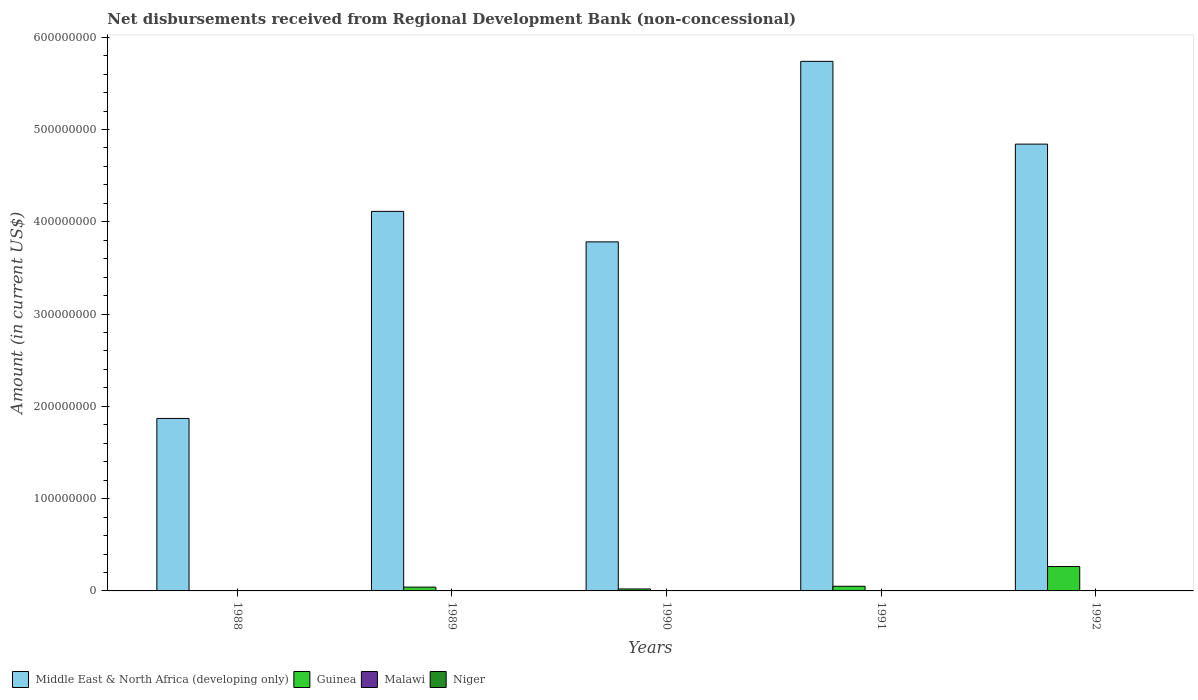How many different coloured bars are there?
Your response must be concise. 2. How many bars are there on the 2nd tick from the left?
Provide a short and direct response. 2. In how many cases, is the number of bars for a given year not equal to the number of legend labels?
Provide a succinct answer. 5. What is the amount of disbursements received from Regional Development Bank in Guinea in 1990?
Provide a short and direct response. 2.14e+06. Across all years, what is the maximum amount of disbursements received from Regional Development Bank in Middle East & North Africa (developing only)?
Offer a terse response. 5.74e+08. In which year was the amount of disbursements received from Regional Development Bank in Middle East & North Africa (developing only) maximum?
Your response must be concise. 1991. What is the total amount of disbursements received from Regional Development Bank in Guinea in the graph?
Make the answer very short. 3.77e+07. What is the difference between the amount of disbursements received from Regional Development Bank in Middle East & North Africa (developing only) in 1988 and that in 1990?
Your answer should be compact. -1.91e+08. What is the difference between the amount of disbursements received from Regional Development Bank in Guinea in 1992 and the amount of disbursements received from Regional Development Bank in Niger in 1990?
Ensure brevity in your answer.  2.64e+07. What is the average amount of disbursements received from Regional Development Bank in Middle East & North Africa (developing only) per year?
Make the answer very short. 4.07e+08. In how many years, is the amount of disbursements received from Regional Development Bank in Guinea greater than 140000000 US$?
Keep it short and to the point. 0. What is the ratio of the amount of disbursements received from Regional Development Bank in Guinea in 1989 to that in 1992?
Make the answer very short. 0.16. What is the difference between the highest and the second highest amount of disbursements received from Regional Development Bank in Guinea?
Your answer should be compact. 2.14e+07. What is the difference between the highest and the lowest amount of disbursements received from Regional Development Bank in Middle East & North Africa (developing only)?
Your answer should be very brief. 3.87e+08. Is the sum of the amount of disbursements received from Regional Development Bank in Guinea in 1989 and 1990 greater than the maximum amount of disbursements received from Regional Development Bank in Malawi across all years?
Give a very brief answer. Yes. Is it the case that in every year, the sum of the amount of disbursements received from Regional Development Bank in Middle East & North Africa (developing only) and amount of disbursements received from Regional Development Bank in Malawi is greater than the sum of amount of disbursements received from Regional Development Bank in Niger and amount of disbursements received from Regional Development Bank in Guinea?
Offer a very short reply. Yes. Is it the case that in every year, the sum of the amount of disbursements received from Regional Development Bank in Middle East & North Africa (developing only) and amount of disbursements received from Regional Development Bank in Niger is greater than the amount of disbursements received from Regional Development Bank in Malawi?
Make the answer very short. Yes. How many bars are there?
Your response must be concise. 9. Are all the bars in the graph horizontal?
Your answer should be compact. No. Does the graph contain grids?
Your response must be concise. No. How many legend labels are there?
Provide a short and direct response. 4. How are the legend labels stacked?
Make the answer very short. Horizontal. What is the title of the graph?
Give a very brief answer. Net disbursements received from Regional Development Bank (non-concessional). Does "Eritrea" appear as one of the legend labels in the graph?
Provide a succinct answer. No. What is the label or title of the X-axis?
Ensure brevity in your answer.  Years. What is the label or title of the Y-axis?
Provide a succinct answer. Amount (in current US$). What is the Amount (in current US$) in Middle East & North Africa (developing only) in 1988?
Offer a very short reply. 1.87e+08. What is the Amount (in current US$) of Malawi in 1988?
Your answer should be very brief. 0. What is the Amount (in current US$) in Middle East & North Africa (developing only) in 1989?
Give a very brief answer. 4.11e+08. What is the Amount (in current US$) in Guinea in 1989?
Ensure brevity in your answer.  4.12e+06. What is the Amount (in current US$) of Malawi in 1989?
Keep it short and to the point. 0. What is the Amount (in current US$) in Niger in 1989?
Provide a short and direct response. 0. What is the Amount (in current US$) of Middle East & North Africa (developing only) in 1990?
Offer a terse response. 3.78e+08. What is the Amount (in current US$) of Guinea in 1990?
Provide a short and direct response. 2.14e+06. What is the Amount (in current US$) in Middle East & North Africa (developing only) in 1991?
Offer a very short reply. 5.74e+08. What is the Amount (in current US$) in Guinea in 1991?
Your answer should be compact. 5.05e+06. What is the Amount (in current US$) in Middle East & North Africa (developing only) in 1992?
Your answer should be very brief. 4.84e+08. What is the Amount (in current US$) in Guinea in 1992?
Give a very brief answer. 2.64e+07. What is the Amount (in current US$) in Niger in 1992?
Offer a terse response. 0. Across all years, what is the maximum Amount (in current US$) of Middle East & North Africa (developing only)?
Provide a succinct answer. 5.74e+08. Across all years, what is the maximum Amount (in current US$) of Guinea?
Make the answer very short. 2.64e+07. Across all years, what is the minimum Amount (in current US$) of Middle East & North Africa (developing only)?
Your answer should be very brief. 1.87e+08. What is the total Amount (in current US$) of Middle East & North Africa (developing only) in the graph?
Your answer should be compact. 2.03e+09. What is the total Amount (in current US$) of Guinea in the graph?
Ensure brevity in your answer.  3.77e+07. What is the difference between the Amount (in current US$) in Middle East & North Africa (developing only) in 1988 and that in 1989?
Ensure brevity in your answer.  -2.24e+08. What is the difference between the Amount (in current US$) in Middle East & North Africa (developing only) in 1988 and that in 1990?
Your answer should be compact. -1.91e+08. What is the difference between the Amount (in current US$) of Middle East & North Africa (developing only) in 1988 and that in 1991?
Your response must be concise. -3.87e+08. What is the difference between the Amount (in current US$) of Middle East & North Africa (developing only) in 1988 and that in 1992?
Your answer should be very brief. -2.97e+08. What is the difference between the Amount (in current US$) in Middle East & North Africa (developing only) in 1989 and that in 1990?
Make the answer very short. 3.30e+07. What is the difference between the Amount (in current US$) of Guinea in 1989 and that in 1990?
Your response must be concise. 1.98e+06. What is the difference between the Amount (in current US$) of Middle East & North Africa (developing only) in 1989 and that in 1991?
Your answer should be compact. -1.63e+08. What is the difference between the Amount (in current US$) in Guinea in 1989 and that in 1991?
Keep it short and to the point. -9.35e+05. What is the difference between the Amount (in current US$) in Middle East & North Africa (developing only) in 1989 and that in 1992?
Offer a terse response. -7.29e+07. What is the difference between the Amount (in current US$) in Guinea in 1989 and that in 1992?
Your response must be concise. -2.23e+07. What is the difference between the Amount (in current US$) in Middle East & North Africa (developing only) in 1990 and that in 1991?
Your answer should be very brief. -1.96e+08. What is the difference between the Amount (in current US$) of Guinea in 1990 and that in 1991?
Offer a very short reply. -2.91e+06. What is the difference between the Amount (in current US$) in Middle East & North Africa (developing only) in 1990 and that in 1992?
Give a very brief answer. -1.06e+08. What is the difference between the Amount (in current US$) of Guinea in 1990 and that in 1992?
Your answer should be compact. -2.43e+07. What is the difference between the Amount (in current US$) of Middle East & North Africa (developing only) in 1991 and that in 1992?
Provide a short and direct response. 8.97e+07. What is the difference between the Amount (in current US$) of Guinea in 1991 and that in 1992?
Provide a succinct answer. -2.14e+07. What is the difference between the Amount (in current US$) of Middle East & North Africa (developing only) in 1988 and the Amount (in current US$) of Guinea in 1989?
Keep it short and to the point. 1.83e+08. What is the difference between the Amount (in current US$) in Middle East & North Africa (developing only) in 1988 and the Amount (in current US$) in Guinea in 1990?
Offer a terse response. 1.85e+08. What is the difference between the Amount (in current US$) in Middle East & North Africa (developing only) in 1988 and the Amount (in current US$) in Guinea in 1991?
Offer a terse response. 1.82e+08. What is the difference between the Amount (in current US$) in Middle East & North Africa (developing only) in 1988 and the Amount (in current US$) in Guinea in 1992?
Offer a very short reply. 1.60e+08. What is the difference between the Amount (in current US$) of Middle East & North Africa (developing only) in 1989 and the Amount (in current US$) of Guinea in 1990?
Offer a very short reply. 4.09e+08. What is the difference between the Amount (in current US$) in Middle East & North Africa (developing only) in 1989 and the Amount (in current US$) in Guinea in 1991?
Keep it short and to the point. 4.06e+08. What is the difference between the Amount (in current US$) of Middle East & North Africa (developing only) in 1989 and the Amount (in current US$) of Guinea in 1992?
Your answer should be very brief. 3.85e+08. What is the difference between the Amount (in current US$) in Middle East & North Africa (developing only) in 1990 and the Amount (in current US$) in Guinea in 1991?
Your answer should be very brief. 3.73e+08. What is the difference between the Amount (in current US$) of Middle East & North Africa (developing only) in 1990 and the Amount (in current US$) of Guinea in 1992?
Offer a very short reply. 3.52e+08. What is the difference between the Amount (in current US$) of Middle East & North Africa (developing only) in 1991 and the Amount (in current US$) of Guinea in 1992?
Provide a succinct answer. 5.47e+08. What is the average Amount (in current US$) in Middle East & North Africa (developing only) per year?
Your answer should be compact. 4.07e+08. What is the average Amount (in current US$) of Guinea per year?
Offer a terse response. 7.55e+06. What is the average Amount (in current US$) of Niger per year?
Provide a succinct answer. 0. In the year 1989, what is the difference between the Amount (in current US$) of Middle East & North Africa (developing only) and Amount (in current US$) of Guinea?
Ensure brevity in your answer.  4.07e+08. In the year 1990, what is the difference between the Amount (in current US$) in Middle East & North Africa (developing only) and Amount (in current US$) in Guinea?
Offer a very short reply. 3.76e+08. In the year 1991, what is the difference between the Amount (in current US$) of Middle East & North Africa (developing only) and Amount (in current US$) of Guinea?
Give a very brief answer. 5.69e+08. In the year 1992, what is the difference between the Amount (in current US$) of Middle East & North Africa (developing only) and Amount (in current US$) of Guinea?
Give a very brief answer. 4.58e+08. What is the ratio of the Amount (in current US$) of Middle East & North Africa (developing only) in 1988 to that in 1989?
Your response must be concise. 0.45. What is the ratio of the Amount (in current US$) of Middle East & North Africa (developing only) in 1988 to that in 1990?
Offer a very short reply. 0.49. What is the ratio of the Amount (in current US$) in Middle East & North Africa (developing only) in 1988 to that in 1991?
Your response must be concise. 0.33. What is the ratio of the Amount (in current US$) in Middle East & North Africa (developing only) in 1988 to that in 1992?
Provide a succinct answer. 0.39. What is the ratio of the Amount (in current US$) of Middle East & North Africa (developing only) in 1989 to that in 1990?
Give a very brief answer. 1.09. What is the ratio of the Amount (in current US$) in Guinea in 1989 to that in 1990?
Offer a very short reply. 1.92. What is the ratio of the Amount (in current US$) of Middle East & North Africa (developing only) in 1989 to that in 1991?
Offer a very short reply. 0.72. What is the ratio of the Amount (in current US$) in Guinea in 1989 to that in 1991?
Provide a short and direct response. 0.81. What is the ratio of the Amount (in current US$) in Middle East & North Africa (developing only) in 1989 to that in 1992?
Offer a terse response. 0.85. What is the ratio of the Amount (in current US$) of Guinea in 1989 to that in 1992?
Ensure brevity in your answer.  0.16. What is the ratio of the Amount (in current US$) of Middle East & North Africa (developing only) in 1990 to that in 1991?
Your answer should be very brief. 0.66. What is the ratio of the Amount (in current US$) in Guinea in 1990 to that in 1991?
Your answer should be very brief. 0.42. What is the ratio of the Amount (in current US$) in Middle East & North Africa (developing only) in 1990 to that in 1992?
Provide a succinct answer. 0.78. What is the ratio of the Amount (in current US$) in Guinea in 1990 to that in 1992?
Give a very brief answer. 0.08. What is the ratio of the Amount (in current US$) in Middle East & North Africa (developing only) in 1991 to that in 1992?
Provide a succinct answer. 1.19. What is the ratio of the Amount (in current US$) of Guinea in 1991 to that in 1992?
Offer a very short reply. 0.19. What is the difference between the highest and the second highest Amount (in current US$) of Middle East & North Africa (developing only)?
Provide a short and direct response. 8.97e+07. What is the difference between the highest and the second highest Amount (in current US$) of Guinea?
Give a very brief answer. 2.14e+07. What is the difference between the highest and the lowest Amount (in current US$) in Middle East & North Africa (developing only)?
Your answer should be very brief. 3.87e+08. What is the difference between the highest and the lowest Amount (in current US$) in Guinea?
Provide a short and direct response. 2.64e+07. 